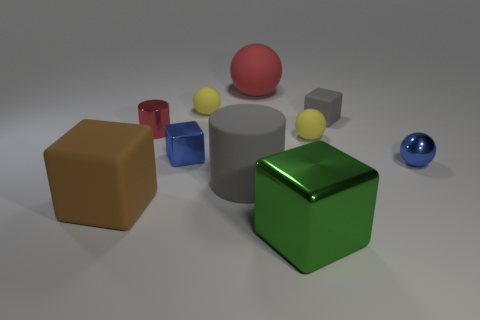Subtract all spheres. How many objects are left? 6 Subtract all small purple metallic cubes. Subtract all matte balls. How many objects are left? 7 Add 5 tiny blue spheres. How many tiny blue spheres are left? 6 Add 3 yellow balls. How many yellow balls exist? 5 Subtract 0 yellow blocks. How many objects are left? 10 